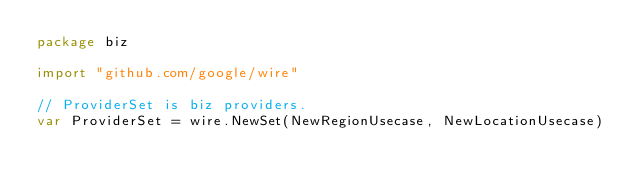<code> <loc_0><loc_0><loc_500><loc_500><_Go_>package biz

import "github.com/google/wire"

// ProviderSet is biz providers.
var ProviderSet = wire.NewSet(NewRegionUsecase, NewLocationUsecase)
</code> 